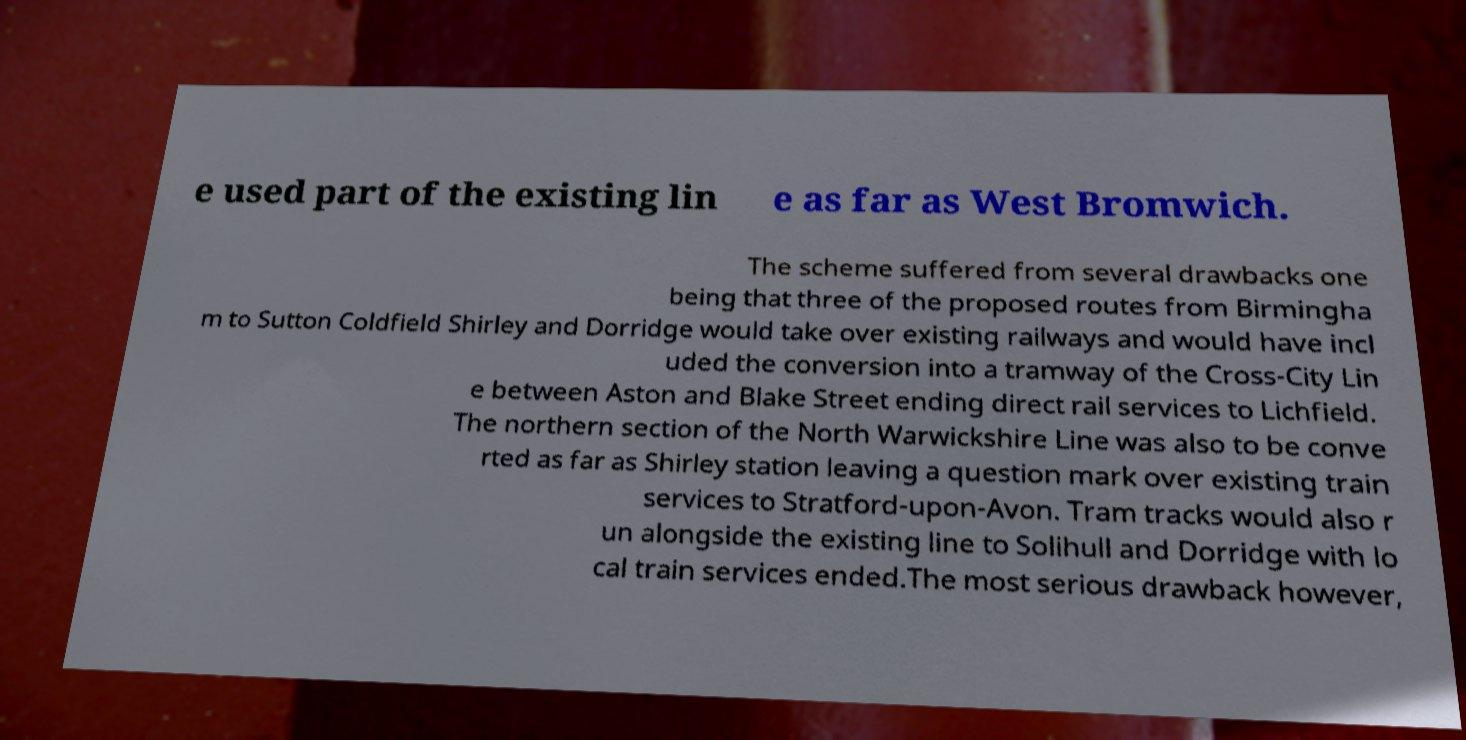Can you read and provide the text displayed in the image?This photo seems to have some interesting text. Can you extract and type it out for me? e used part of the existing lin e as far as West Bromwich. The scheme suffered from several drawbacks one being that three of the proposed routes from Birmingha m to Sutton Coldfield Shirley and Dorridge would take over existing railways and would have incl uded the conversion into a tramway of the Cross-City Lin e between Aston and Blake Street ending direct rail services to Lichfield. The northern section of the North Warwickshire Line was also to be conve rted as far as Shirley station leaving a question mark over existing train services to Stratford-upon-Avon. Tram tracks would also r un alongside the existing line to Solihull and Dorridge with lo cal train services ended.The most serious drawback however, 